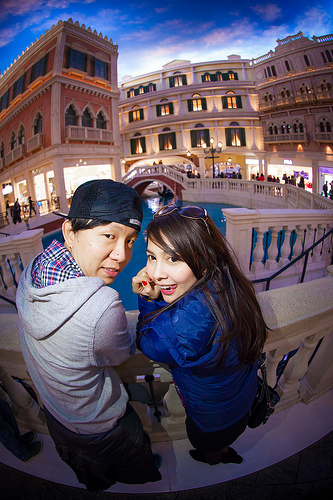<image>
Is there a girl on the water? No. The girl is not positioned on the water. They may be near each other, but the girl is not supported by or resting on top of the water. Is the boy to the right of the girl? No. The boy is not to the right of the girl. The horizontal positioning shows a different relationship. Is there a boy in front of the girl? No. The boy is not in front of the girl. The spatial positioning shows a different relationship between these objects. 